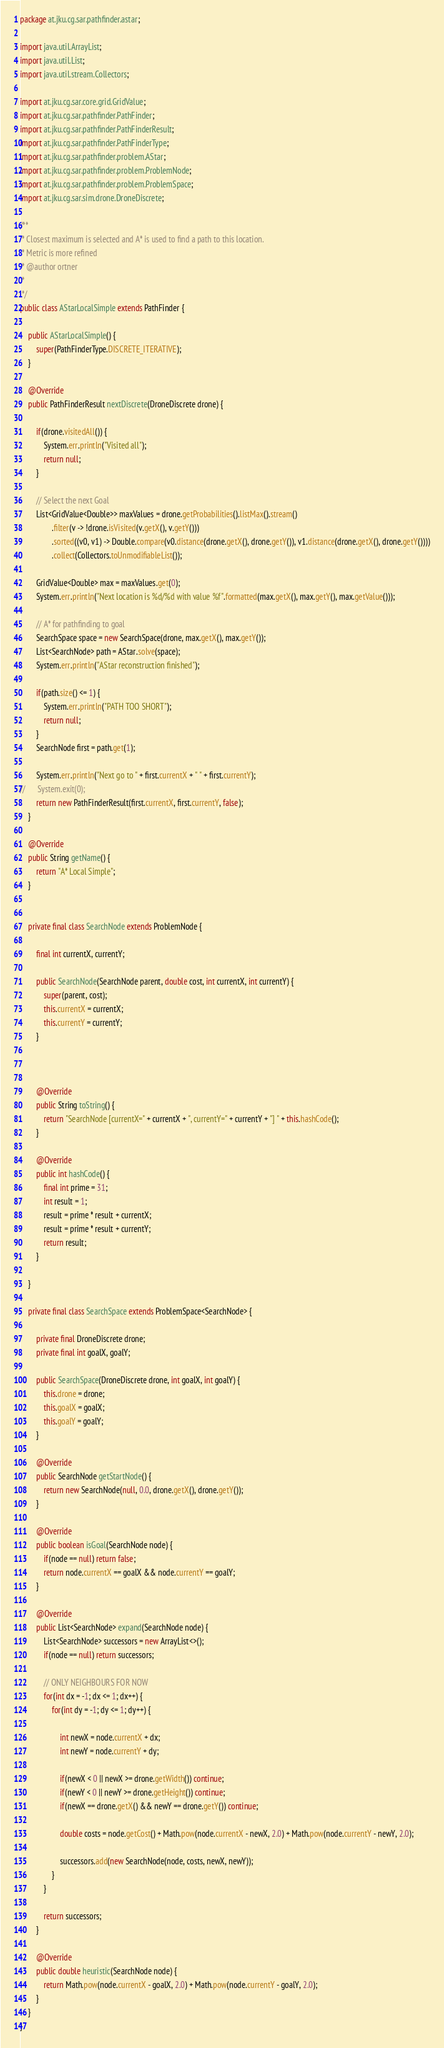Convert code to text. <code><loc_0><loc_0><loc_500><loc_500><_Java_>package at.jku.cg.sar.pathfinder.astar;

import java.util.ArrayList;
import java.util.List;
import java.util.stream.Collectors;

import at.jku.cg.sar.core.grid.GridValue;
import at.jku.cg.sar.pathfinder.PathFinder;
import at.jku.cg.sar.pathfinder.PathFinderResult;
import at.jku.cg.sar.pathfinder.PathFinderType;
import at.jku.cg.sar.pathfinder.problem.AStar;
import at.jku.cg.sar.pathfinder.problem.ProblemNode;
import at.jku.cg.sar.pathfinder.problem.ProblemSpace;
import at.jku.cg.sar.sim.drone.DroneDiscrete;

/**
 * Closest maximum is selected and A* is used to find a path to this location.
 * Metric is more refined
 * @author ortner
 *
 */
public class AStarLocalSimple extends PathFinder {

	public AStarLocalSimple() {
		super(PathFinderType.DISCRETE_ITERATIVE);
	}

	@Override
	public PathFinderResult nextDiscrete(DroneDiscrete drone) {
		
		if(drone.visitedAll()) {
			System.err.println("Visited all");
			return null;
		}
		
		// Select the next Goal
		List<GridValue<Double>> maxValues = drone.getProbabilities().listMax().stream()
				.filter(v -> !drone.isVisited(v.getX(), v.getY()))
				.sorted((v0, v1) -> Double.compare(v0.distance(drone.getX(), drone.getY()), v1.distance(drone.getX(), drone.getY())))
				.collect(Collectors.toUnmodifiableList());
		
		GridValue<Double> max = maxValues.get(0);
		System.err.println("Next location is %d/%d with value %f".formatted(max.getX(), max.getY(), max.getValue()));
		
		// A* for pathfinding to goal
		SearchSpace space = new SearchSpace(drone, max.getX(), max.getY());
		List<SearchNode> path = AStar.solve(space);
		System.err.println("AStar reconstruction finished");
		
		if(path.size() <= 1) {
			System.err.println("PATH TOO SHORT");
			return null;
		}
		SearchNode first = path.get(1);
		
		System.err.println("Next go to " + first.currentX + " " + first.currentY);
//		System.exit(0);
		return new PathFinderResult(first.currentX, first.currentY, false);
	}

	@Override
	public String getName() {
		return "A* Local Simple";
	}
	
	
	private final class SearchNode extends ProblemNode {

		final int currentX, currentY;
		
		public SearchNode(SearchNode parent, double cost, int currentX, int currentY) {
			super(parent, cost);
			this.currentX = currentX;
			this.currentY = currentY;
		}
		
		

		@Override
		public String toString() {
			return "SearchNode [currentX=" + currentX + ", currentY=" + currentY + "] " + this.hashCode();
		}

		@Override
		public int hashCode() {
			final int prime = 31;
			int result = 1;
			result = prime * result + currentX;
			result = prime * result + currentY;
			return result;
		}

	}
	
	private final class SearchSpace extends ProblemSpace<SearchNode> {

		private final DroneDiscrete drone;
		private final int goalX, goalY;
		
		public SearchSpace(DroneDiscrete drone, int goalX, int goalY) {
			this.drone = drone;
			this.goalX = goalX;
			this.goalY = goalY;
		}

		@Override
		public SearchNode getStartNode() {
			return new SearchNode(null, 0.0, drone.getX(), drone.getY());
		}

		@Override
		public boolean isGoal(SearchNode node) {
			if(node == null) return false;
			return node.currentX == goalX && node.currentY == goalY;
		}

		@Override
		public List<SearchNode> expand(SearchNode node) {
			List<SearchNode> successors = new ArrayList<>();
			if(node == null) return successors;

			// ONLY NEIGHBOURS FOR NOW
			for(int dx = -1; dx <= 1; dx++) {
				for(int dy = -1; dy <= 1; dy++) {
					
					int newX = node.currentX + dx;
					int newY = node.currentY + dy;
					
					if(newX < 0 || newX >= drone.getWidth()) continue;
					if(newY < 0 || newY >= drone.getHeight()) continue;
					if(newX == drone.getX() && newY == drone.getY()) continue;
					
					double costs = node.getCost() + Math.pow(node.currentX - newX, 2.0) + Math.pow(node.currentY - newY, 2.0);
					
					successors.add(new SearchNode(node, costs, newX, newY));
				}
			}

			return successors;
		}

		@Override
		public double heuristic(SearchNode node) {
			return Math.pow(node.currentX - goalX, 2.0) + Math.pow(node.currentY - goalY, 2.0);
		}
	}
}
</code> 